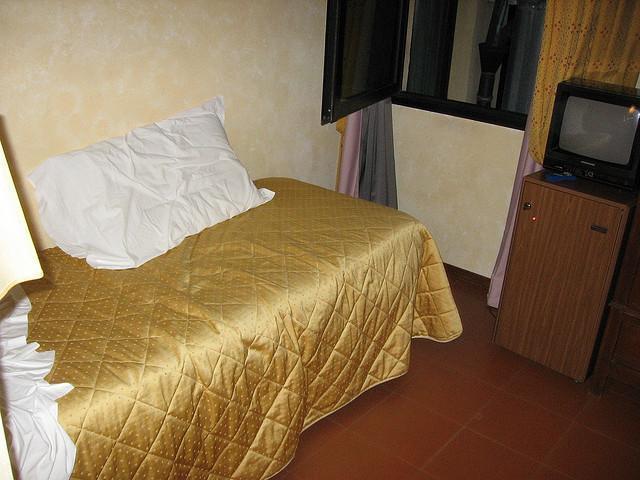What color is the sheet covering the small twin bed on the corner of the room?
Choose the correct response and explain in the format: 'Answer: answer
Rationale: rationale.'
Options: Green, blue, pink, yellow. Answer: yellow.
Rationale: The color is yellow. 